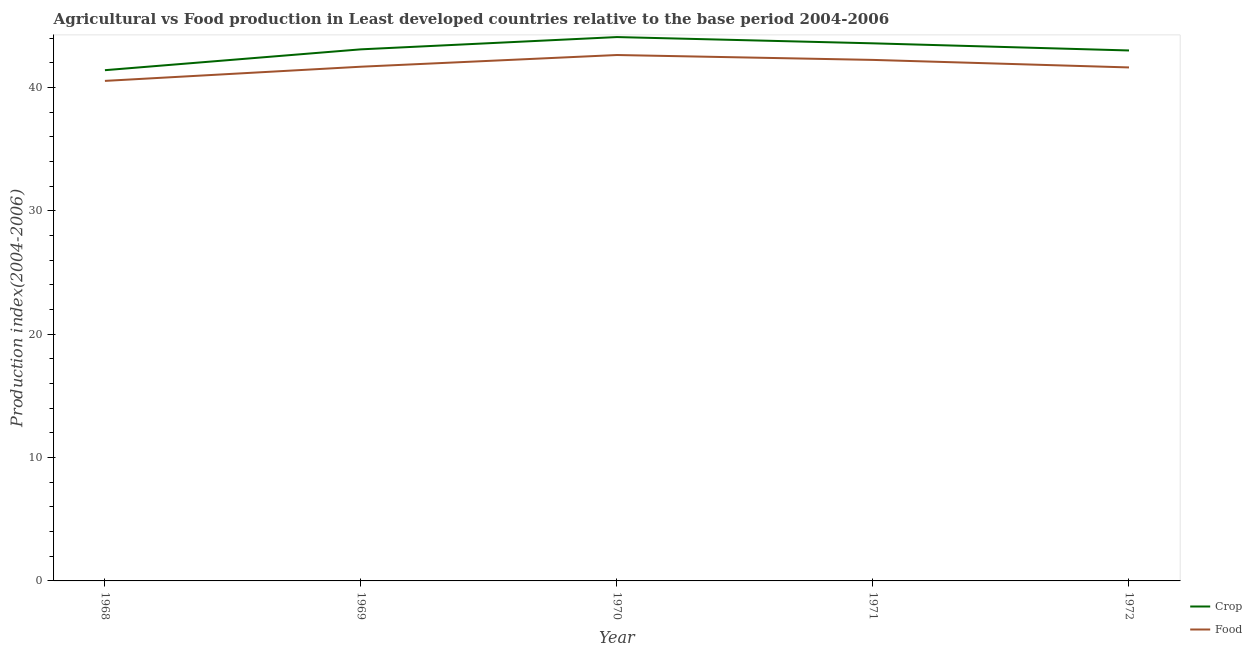How many different coloured lines are there?
Keep it short and to the point. 2. Does the line corresponding to crop production index intersect with the line corresponding to food production index?
Provide a succinct answer. No. What is the crop production index in 1972?
Offer a terse response. 42.99. Across all years, what is the maximum food production index?
Keep it short and to the point. 42.62. Across all years, what is the minimum food production index?
Your answer should be very brief. 40.53. In which year was the food production index maximum?
Provide a short and direct response. 1970. In which year was the crop production index minimum?
Provide a succinct answer. 1968. What is the total crop production index in the graph?
Offer a very short reply. 215.12. What is the difference between the crop production index in 1968 and that in 1970?
Keep it short and to the point. -2.68. What is the difference between the crop production index in 1968 and the food production index in 1972?
Provide a short and direct response. -0.22. What is the average crop production index per year?
Your answer should be very brief. 43.02. In the year 1969, what is the difference between the crop production index and food production index?
Provide a short and direct response. 1.41. What is the ratio of the crop production index in 1969 to that in 1971?
Provide a succinct answer. 0.99. What is the difference between the highest and the second highest food production index?
Offer a very short reply. 0.4. What is the difference between the highest and the lowest food production index?
Offer a terse response. 2.1. In how many years, is the food production index greater than the average food production index taken over all years?
Make the answer very short. 2. Is the crop production index strictly greater than the food production index over the years?
Your response must be concise. Yes. How many lines are there?
Provide a short and direct response. 2. How many years are there in the graph?
Offer a terse response. 5. What is the difference between two consecutive major ticks on the Y-axis?
Keep it short and to the point. 10. Does the graph contain any zero values?
Make the answer very short. No. How many legend labels are there?
Ensure brevity in your answer.  2. What is the title of the graph?
Keep it short and to the point. Agricultural vs Food production in Least developed countries relative to the base period 2004-2006. What is the label or title of the X-axis?
Keep it short and to the point. Year. What is the label or title of the Y-axis?
Offer a terse response. Production index(2004-2006). What is the Production index(2004-2006) of Crop in 1968?
Your response must be concise. 41.39. What is the Production index(2004-2006) of Food in 1968?
Offer a very short reply. 40.53. What is the Production index(2004-2006) in Crop in 1969?
Your answer should be compact. 43.08. What is the Production index(2004-2006) of Food in 1969?
Offer a very short reply. 41.68. What is the Production index(2004-2006) of Crop in 1970?
Keep it short and to the point. 44.08. What is the Production index(2004-2006) of Food in 1970?
Provide a succinct answer. 42.62. What is the Production index(2004-2006) of Crop in 1971?
Provide a succinct answer. 43.57. What is the Production index(2004-2006) of Food in 1971?
Offer a terse response. 42.23. What is the Production index(2004-2006) in Crop in 1972?
Your response must be concise. 42.99. What is the Production index(2004-2006) in Food in 1972?
Your answer should be compact. 41.62. Across all years, what is the maximum Production index(2004-2006) of Crop?
Ensure brevity in your answer.  44.08. Across all years, what is the maximum Production index(2004-2006) in Food?
Your answer should be compact. 42.62. Across all years, what is the minimum Production index(2004-2006) in Crop?
Your answer should be very brief. 41.39. Across all years, what is the minimum Production index(2004-2006) in Food?
Your answer should be very brief. 40.53. What is the total Production index(2004-2006) of Crop in the graph?
Give a very brief answer. 215.12. What is the total Production index(2004-2006) of Food in the graph?
Your response must be concise. 208.67. What is the difference between the Production index(2004-2006) in Crop in 1968 and that in 1969?
Your answer should be very brief. -1.69. What is the difference between the Production index(2004-2006) in Food in 1968 and that in 1969?
Offer a terse response. -1.15. What is the difference between the Production index(2004-2006) of Crop in 1968 and that in 1970?
Your answer should be very brief. -2.68. What is the difference between the Production index(2004-2006) in Food in 1968 and that in 1970?
Make the answer very short. -2.1. What is the difference between the Production index(2004-2006) of Crop in 1968 and that in 1971?
Give a very brief answer. -2.18. What is the difference between the Production index(2004-2006) of Food in 1968 and that in 1971?
Offer a terse response. -1.7. What is the difference between the Production index(2004-2006) in Crop in 1968 and that in 1972?
Offer a terse response. -1.6. What is the difference between the Production index(2004-2006) in Food in 1968 and that in 1972?
Keep it short and to the point. -1.09. What is the difference between the Production index(2004-2006) in Crop in 1969 and that in 1970?
Your answer should be compact. -0.99. What is the difference between the Production index(2004-2006) in Food in 1969 and that in 1970?
Offer a terse response. -0.95. What is the difference between the Production index(2004-2006) of Crop in 1969 and that in 1971?
Make the answer very short. -0.49. What is the difference between the Production index(2004-2006) of Food in 1969 and that in 1971?
Your response must be concise. -0.55. What is the difference between the Production index(2004-2006) of Crop in 1969 and that in 1972?
Your answer should be very brief. 0.09. What is the difference between the Production index(2004-2006) of Food in 1969 and that in 1972?
Your answer should be compact. 0.06. What is the difference between the Production index(2004-2006) in Crop in 1970 and that in 1971?
Give a very brief answer. 0.51. What is the difference between the Production index(2004-2006) of Food in 1970 and that in 1971?
Your answer should be compact. 0.4. What is the difference between the Production index(2004-2006) of Crop in 1970 and that in 1972?
Your answer should be very brief. 1.09. What is the difference between the Production index(2004-2006) in Food in 1970 and that in 1972?
Your response must be concise. 1.01. What is the difference between the Production index(2004-2006) in Crop in 1971 and that in 1972?
Offer a very short reply. 0.58. What is the difference between the Production index(2004-2006) of Food in 1971 and that in 1972?
Ensure brevity in your answer.  0.61. What is the difference between the Production index(2004-2006) in Crop in 1968 and the Production index(2004-2006) in Food in 1969?
Ensure brevity in your answer.  -0.28. What is the difference between the Production index(2004-2006) in Crop in 1968 and the Production index(2004-2006) in Food in 1970?
Make the answer very short. -1.23. What is the difference between the Production index(2004-2006) of Crop in 1968 and the Production index(2004-2006) of Food in 1971?
Provide a short and direct response. -0.83. What is the difference between the Production index(2004-2006) in Crop in 1968 and the Production index(2004-2006) in Food in 1972?
Make the answer very short. -0.22. What is the difference between the Production index(2004-2006) of Crop in 1969 and the Production index(2004-2006) of Food in 1970?
Ensure brevity in your answer.  0.46. What is the difference between the Production index(2004-2006) in Crop in 1969 and the Production index(2004-2006) in Food in 1971?
Offer a very short reply. 0.86. What is the difference between the Production index(2004-2006) of Crop in 1969 and the Production index(2004-2006) of Food in 1972?
Offer a terse response. 1.47. What is the difference between the Production index(2004-2006) in Crop in 1970 and the Production index(2004-2006) in Food in 1971?
Your answer should be very brief. 1.85. What is the difference between the Production index(2004-2006) in Crop in 1970 and the Production index(2004-2006) in Food in 1972?
Ensure brevity in your answer.  2.46. What is the difference between the Production index(2004-2006) of Crop in 1971 and the Production index(2004-2006) of Food in 1972?
Provide a succinct answer. 1.95. What is the average Production index(2004-2006) in Crop per year?
Offer a very short reply. 43.02. What is the average Production index(2004-2006) in Food per year?
Offer a very short reply. 41.73. In the year 1968, what is the difference between the Production index(2004-2006) in Crop and Production index(2004-2006) in Food?
Keep it short and to the point. 0.87. In the year 1969, what is the difference between the Production index(2004-2006) of Crop and Production index(2004-2006) of Food?
Provide a short and direct response. 1.41. In the year 1970, what is the difference between the Production index(2004-2006) in Crop and Production index(2004-2006) in Food?
Your response must be concise. 1.46. In the year 1971, what is the difference between the Production index(2004-2006) in Crop and Production index(2004-2006) in Food?
Keep it short and to the point. 1.34. In the year 1972, what is the difference between the Production index(2004-2006) of Crop and Production index(2004-2006) of Food?
Give a very brief answer. 1.38. What is the ratio of the Production index(2004-2006) in Crop in 1968 to that in 1969?
Keep it short and to the point. 0.96. What is the ratio of the Production index(2004-2006) of Food in 1968 to that in 1969?
Offer a terse response. 0.97. What is the ratio of the Production index(2004-2006) of Crop in 1968 to that in 1970?
Your response must be concise. 0.94. What is the ratio of the Production index(2004-2006) in Food in 1968 to that in 1970?
Your response must be concise. 0.95. What is the ratio of the Production index(2004-2006) in Food in 1968 to that in 1971?
Provide a succinct answer. 0.96. What is the ratio of the Production index(2004-2006) in Crop in 1968 to that in 1972?
Ensure brevity in your answer.  0.96. What is the ratio of the Production index(2004-2006) in Food in 1968 to that in 1972?
Provide a succinct answer. 0.97. What is the ratio of the Production index(2004-2006) in Crop in 1969 to that in 1970?
Offer a terse response. 0.98. What is the ratio of the Production index(2004-2006) in Food in 1969 to that in 1970?
Your answer should be very brief. 0.98. What is the ratio of the Production index(2004-2006) in Food in 1969 to that in 1971?
Give a very brief answer. 0.99. What is the ratio of the Production index(2004-2006) in Crop in 1970 to that in 1971?
Your answer should be compact. 1.01. What is the ratio of the Production index(2004-2006) in Food in 1970 to that in 1971?
Keep it short and to the point. 1.01. What is the ratio of the Production index(2004-2006) of Crop in 1970 to that in 1972?
Provide a succinct answer. 1.03. What is the ratio of the Production index(2004-2006) in Food in 1970 to that in 1972?
Ensure brevity in your answer.  1.02. What is the ratio of the Production index(2004-2006) in Crop in 1971 to that in 1972?
Your answer should be very brief. 1.01. What is the ratio of the Production index(2004-2006) in Food in 1971 to that in 1972?
Give a very brief answer. 1.01. What is the difference between the highest and the second highest Production index(2004-2006) in Crop?
Offer a very short reply. 0.51. What is the difference between the highest and the second highest Production index(2004-2006) of Food?
Offer a terse response. 0.4. What is the difference between the highest and the lowest Production index(2004-2006) in Crop?
Offer a very short reply. 2.68. What is the difference between the highest and the lowest Production index(2004-2006) in Food?
Your answer should be very brief. 2.1. 